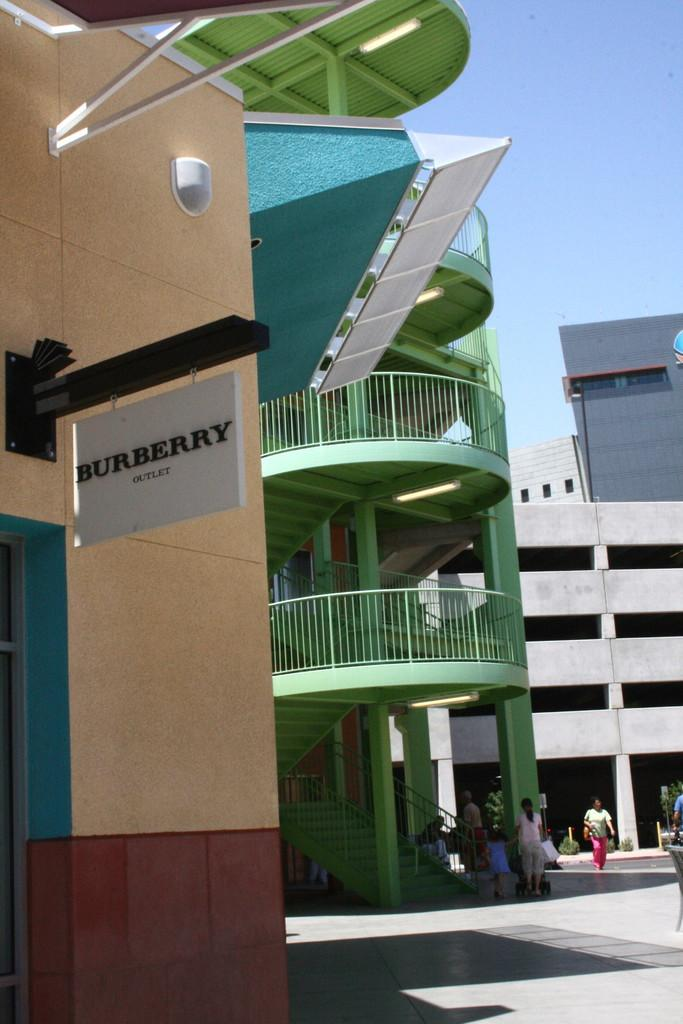What type of surface can be seen in the image? Ground is visible in the image. What are the people in the image doing? There are people standing in the image. What architectural feature is present in the image? There are stairs in the image. What safety feature is present in the image? There is railing in the image. What object is white in color in the image? There is a white-colored board in the image. What type of structures can be seen in the image? There are buildings in the image. What part of the natural environment is visible in the image? The sky is visible in the background of the image. How many books are stacked on the hole in the image? There is no hole or books present in the image. What type of patch is sewn onto the person's clothing in the image? There is no patch or clothing visible in the image. 